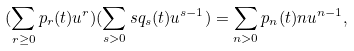<formula> <loc_0><loc_0><loc_500><loc_500>( \sum _ { r \geq 0 } p _ { r } ( t ) u ^ { r } ) ( \sum _ { s > 0 } s q _ { s } ( t ) u ^ { s - 1 } ) = \sum _ { n > 0 } p _ { n } ( t ) n u ^ { n - 1 } ,</formula> 